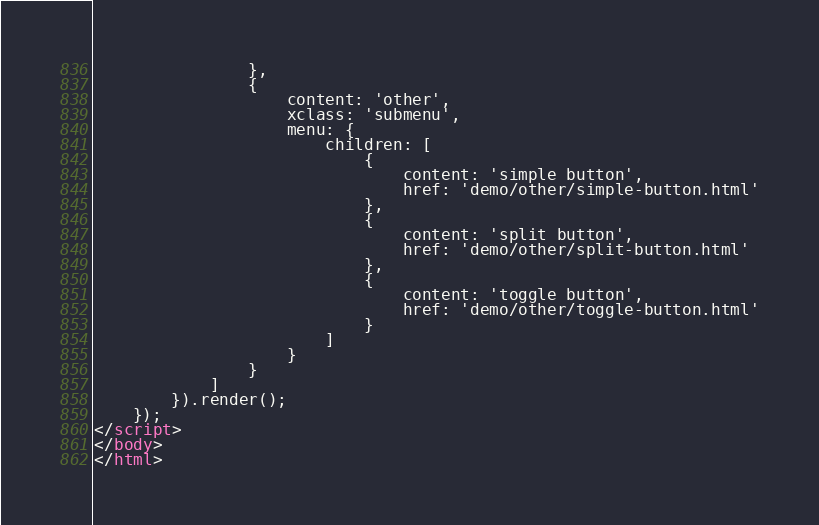<code> <loc_0><loc_0><loc_500><loc_500><_HTML_>                },
                {
                    content: 'other',
                    xclass: 'submenu',
                    menu: {
                        children: [
                            {
                                content: 'simple button',
                                href: 'demo/other/simple-button.html'
                            },
                            {
                                content: 'split button',
                                href: 'demo/other/split-button.html'
                            },
                            {
                                content: 'toggle button',
                                href: 'demo/other/toggle-button.html'
                            }
                        ]
                    }
                }
            ]
        }).render();
    });
</script>
</body>
</html></code> 